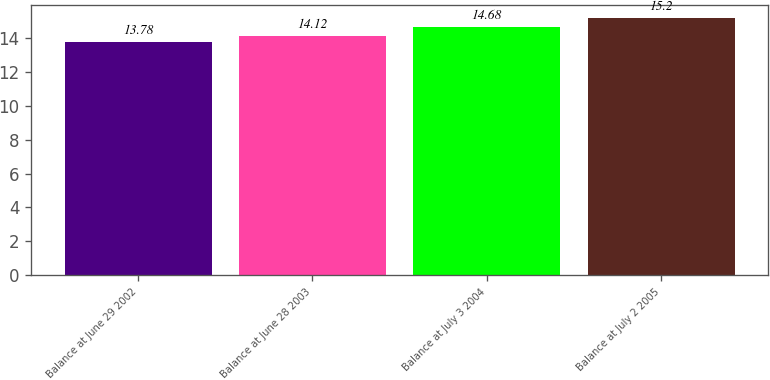Convert chart. <chart><loc_0><loc_0><loc_500><loc_500><bar_chart><fcel>Balance at June 29 2002<fcel>Balance at June 28 2003<fcel>Balance at July 3 2004<fcel>Balance at July 2 2005<nl><fcel>13.78<fcel>14.12<fcel>14.68<fcel>15.2<nl></chart> 